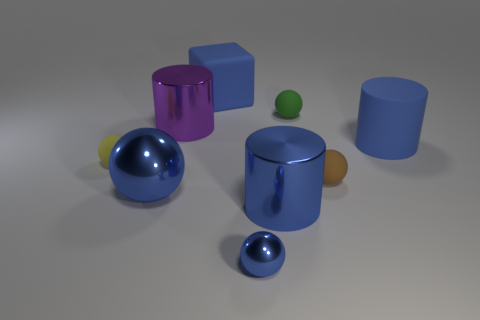Subtract 2 spheres. How many spheres are left? 3 Subtract all large blue spheres. How many spheres are left? 4 Subtract all brown spheres. How many spheres are left? 4 Subtract all red balls. Subtract all blue cylinders. How many balls are left? 5 Add 1 rubber cylinders. How many objects exist? 10 Subtract all spheres. How many objects are left? 4 Subtract all large metallic things. Subtract all yellow spheres. How many objects are left? 5 Add 5 green things. How many green things are left? 6 Add 5 large things. How many large things exist? 10 Subtract 2 blue cylinders. How many objects are left? 7 